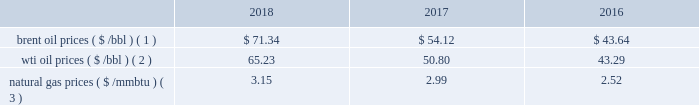Bhge 2018 form 10-k | 31 business environment the following discussion and analysis summarizes the significant factors affecting our results of operations , financial condition and liquidity position as of and for the year ended december 31 , 2018 , 2017 and 2016 , and should be read in conjunction with the consolidated and combined financial statements and related notes of the company .
We operate in more than 120 countries helping customers find , evaluate , drill , produce , transport and process hydrocarbon resources .
Our revenue is predominately generated from the sale of products and services to major , national , and independent oil and natural gas companies worldwide , and is dependent on spending by our customers for oil and natural gas exploration , field development and production .
This spending is driven by a number of factors , including our customers' forecasts of future energy demand and supply , their access to resources to develop and produce oil and natural gas , their ability to fund their capital programs , the impact of new government regulations and most importantly , their expectations for oil and natural gas prices as a key driver of their cash flows .
Oil and natural gas prices oil and natural gas prices are summarized in the table below as averages of the daily closing prices during each of the periods indicated. .
Brent oil prices ( $ /bbl ) ( 1 ) $ 71.34 $ 54.12 $ 43.64 wti oil prices ( $ /bbl ) ( 2 ) 65.23 50.80 43.29 natural gas prices ( $ /mmbtu ) ( 3 ) 3.15 2.99 2.52 ( 1 ) energy information administration ( eia ) europe brent spot price per barrel ( 2 ) eia cushing , ok wti ( west texas intermediate ) spot price ( 3 ) eia henry hub natural gas spot price per million british thermal unit 2018 demonstrated the volatility of the oil and gas market .
Through the first three quarters of 2018 , we experienced stability in the north american and international markets .
However , in the fourth quarter of 2018 commodity prices dropped nearly 40% ( 40 % ) resulting in increased customer uncertainty .
From an offshore standpoint , through most of 2018 , we saw multiple large offshore projects reach positive final investment decisions , and the lng market and outlook improved throughout 2018 , driven by increased demand globally .
In 2018 , the first large north american lng positive final investment decision was reached .
Outside of north america , customer spending is highly driven by brent oil prices , which increased on average throughout the year .
Average brent oil prices increased to $ 71.34/bbl in 2018 from $ 54.12/bbl in 2017 , and ranged from a low of $ 50.57/bbl in december 2018 , to a high of $ 86.07/bbl in october 2018 .
For the first three quarters of 2018 , brent oil prices increased sequentially .
However , in the fourth quarter , brent oil prices declined 39% ( 39 % ) versus the end of the third quarter , as a result of increased supply from the u.s. , worries of a global economic slowdown , and lower than expected production cuts .
In north america , customer spending is highly driven by wti oil prices , which similar to brent oil prices , on average increased throughout the year .
Average wti oil prices increased to $ 65.23/bbl in 2018 from $ 50.80/bbl in 2017 , and ranged from a low of $ 44.48/bbl in december 2018 , to a high of $ 77.41/bbl in june 2018 .
In north america , natural gas prices , as measured by the henry hub natural gas spot price , averaged $ 3.15/ mmbtu in 2018 , representing a 6% ( 6 % ) increase over the prior year .
Throughout the year , henry hub natural gas spot prices ranged from a high of $ 6.24/mmbtu in january 2018 to a low of $ 2.49/mmbtu in february 2018 .
According to the u.s .
Department of energy ( doe ) , working natural gas in storage at the end of 2018 was 2705 billion cubic feet ( bcf ) , which was 15.6% ( 15.6 % ) , or 421 bcf , below the corresponding week in 2017. .
What is the average percent change in natural gas prices? 
Computations: ((((3.15 - 2.99) / 2.99) + ((2.99 - 2.52) / 2.52)) / 2)
Answer: 0.12001. Bhge 2018 form 10-k | 31 business environment the following discussion and analysis summarizes the significant factors affecting our results of operations , financial condition and liquidity position as of and for the year ended december 31 , 2018 , 2017 and 2016 , and should be read in conjunction with the consolidated and combined financial statements and related notes of the company .
We operate in more than 120 countries helping customers find , evaluate , drill , produce , transport and process hydrocarbon resources .
Our revenue is predominately generated from the sale of products and services to major , national , and independent oil and natural gas companies worldwide , and is dependent on spending by our customers for oil and natural gas exploration , field development and production .
This spending is driven by a number of factors , including our customers' forecasts of future energy demand and supply , their access to resources to develop and produce oil and natural gas , their ability to fund their capital programs , the impact of new government regulations and most importantly , their expectations for oil and natural gas prices as a key driver of their cash flows .
Oil and natural gas prices oil and natural gas prices are summarized in the table below as averages of the daily closing prices during each of the periods indicated. .
Brent oil prices ( $ /bbl ) ( 1 ) $ 71.34 $ 54.12 $ 43.64 wti oil prices ( $ /bbl ) ( 2 ) 65.23 50.80 43.29 natural gas prices ( $ /mmbtu ) ( 3 ) 3.15 2.99 2.52 ( 1 ) energy information administration ( eia ) europe brent spot price per barrel ( 2 ) eia cushing , ok wti ( west texas intermediate ) spot price ( 3 ) eia henry hub natural gas spot price per million british thermal unit 2018 demonstrated the volatility of the oil and gas market .
Through the first three quarters of 2018 , we experienced stability in the north american and international markets .
However , in the fourth quarter of 2018 commodity prices dropped nearly 40% ( 40 % ) resulting in increased customer uncertainty .
From an offshore standpoint , through most of 2018 , we saw multiple large offshore projects reach positive final investment decisions , and the lng market and outlook improved throughout 2018 , driven by increased demand globally .
In 2018 , the first large north american lng positive final investment decision was reached .
Outside of north america , customer spending is highly driven by brent oil prices , which increased on average throughout the year .
Average brent oil prices increased to $ 71.34/bbl in 2018 from $ 54.12/bbl in 2017 , and ranged from a low of $ 50.57/bbl in december 2018 , to a high of $ 86.07/bbl in october 2018 .
For the first three quarters of 2018 , brent oil prices increased sequentially .
However , in the fourth quarter , brent oil prices declined 39% ( 39 % ) versus the end of the third quarter , as a result of increased supply from the u.s. , worries of a global economic slowdown , and lower than expected production cuts .
In north america , customer spending is highly driven by wti oil prices , which similar to brent oil prices , on average increased throughout the year .
Average wti oil prices increased to $ 65.23/bbl in 2018 from $ 50.80/bbl in 2017 , and ranged from a low of $ 44.48/bbl in december 2018 , to a high of $ 77.41/bbl in june 2018 .
In north america , natural gas prices , as measured by the henry hub natural gas spot price , averaged $ 3.15/ mmbtu in 2018 , representing a 6% ( 6 % ) increase over the prior year .
Throughout the year , henry hub natural gas spot prices ranged from a high of $ 6.24/mmbtu in january 2018 to a low of $ 2.49/mmbtu in february 2018 .
According to the u.s .
Department of energy ( doe ) , working natural gas in storage at the end of 2018 was 2705 billion cubic feet ( bcf ) , which was 15.6% ( 15.6 % ) , or 421 bcf , below the corresponding week in 2017. .
What is the growth rate in brent oil prices from 2016 to 2017? 
Computations: ((54.12 - 43.64) / 43.64)
Answer: 0.24015. 